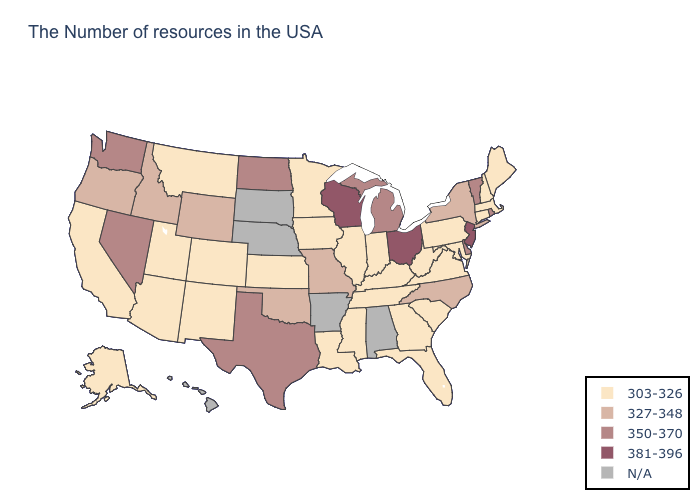Which states have the highest value in the USA?
Be succinct. New Jersey, Ohio, Wisconsin. Does the first symbol in the legend represent the smallest category?
Give a very brief answer. Yes. What is the value of Nebraska?
Short answer required. N/A. What is the value of Georgia?
Keep it brief. 303-326. What is the highest value in states that border South Dakota?
Quick response, please. 350-370. What is the value of North Dakota?
Answer briefly. 350-370. Does Vermont have the highest value in the Northeast?
Keep it brief. No. Name the states that have a value in the range 327-348?
Answer briefly. New York, North Carolina, Missouri, Oklahoma, Wyoming, Idaho, Oregon. Name the states that have a value in the range 327-348?
Write a very short answer. New York, North Carolina, Missouri, Oklahoma, Wyoming, Idaho, Oregon. What is the highest value in the MidWest ?
Keep it brief. 381-396. Among the states that border Maine , which have the highest value?
Concise answer only. New Hampshire. Does Washington have the lowest value in the USA?
Quick response, please. No. Name the states that have a value in the range 350-370?
Answer briefly. Rhode Island, Vermont, Delaware, Michigan, Texas, North Dakota, Nevada, Washington. Name the states that have a value in the range 350-370?
Be succinct. Rhode Island, Vermont, Delaware, Michigan, Texas, North Dakota, Nevada, Washington. 